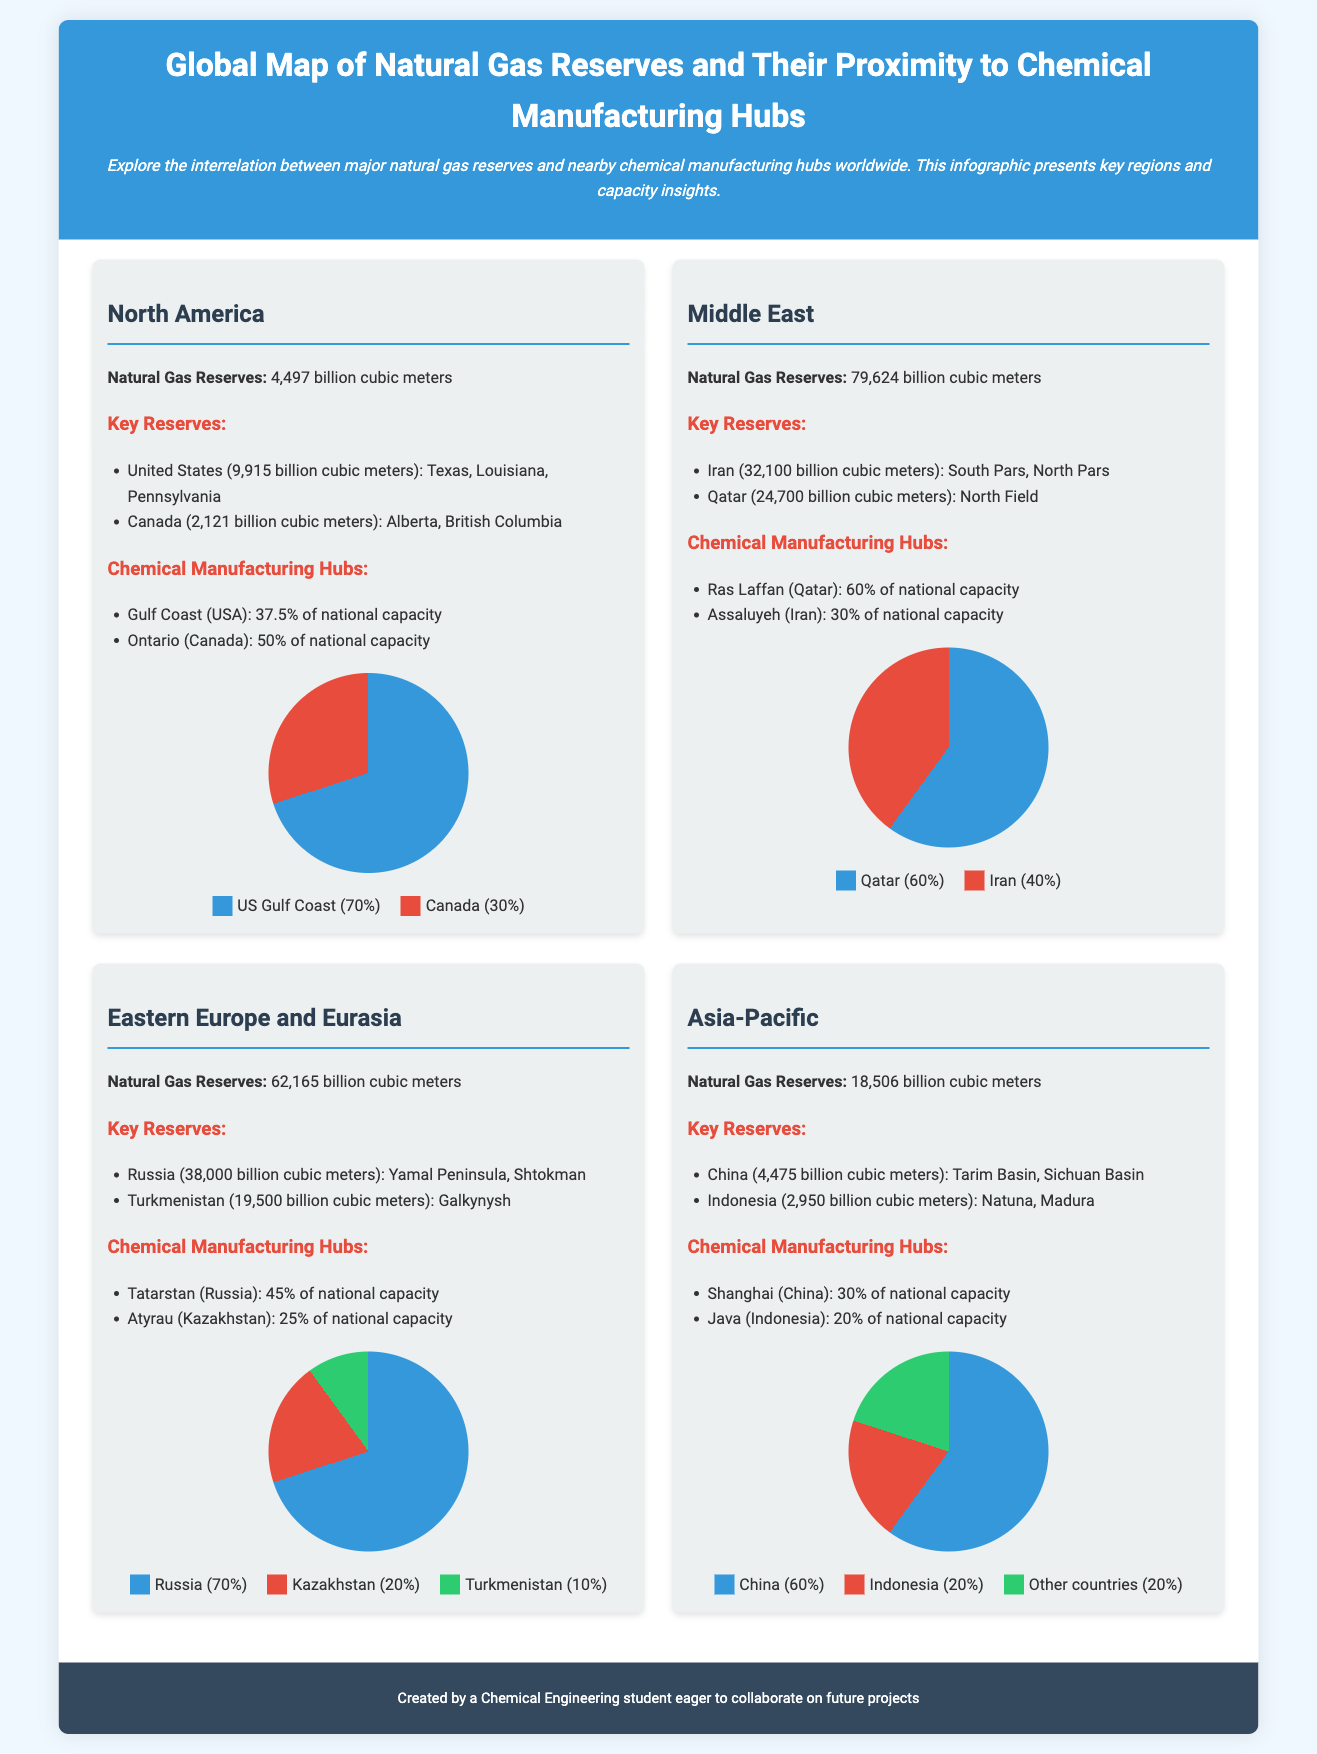What are the total natural gas reserves in North America? The total natural gas reserves in North America are directly mentioned in the document, which states 4,497 billion cubic meters.
Answer: 4,497 billion cubic meters Which country has the largest natural gas reserves in the Middle East? The document lists Iran with 32,100 billion cubic meters of reserves as the country with the largest reserves in the Middle East.
Answer: Iran What percentage of national capacity does the Gulf Coast in the USA represent? The document states that the Gulf Coast (USA) holds 37.5% of the national capacity for chemical manufacturing.
Answer: 37.5% What is the total natural gas reserve of Russia? According to the document, Russia has 38,000 billion cubic meters of natural gas reserves.
Answer: 38,000 billion cubic meters How much of the Asia-Pacific's capacity is represented by China? The document indicates that China represents 60% of the capacity in the Asia-Pacific region.
Answer: 60% Which region has the highest natural gas reserves overall? By comparing the figures provided in the document, the Middle East has the highest natural gas reserves at 79,624 billion cubic meters.
Answer: Middle East What is the chemical manufacturing hub in Ontario known for? The document states that Ontario (Canada) constitutes 50% of the national chemical manufacturing capacity.
Answer: 50% Which two countries have key reserves in the Asia-Pacific region? The key reserves in the Asia-Pacific region are held by China and Indonesia, as specified in the document.
Answer: China and Indonesia 